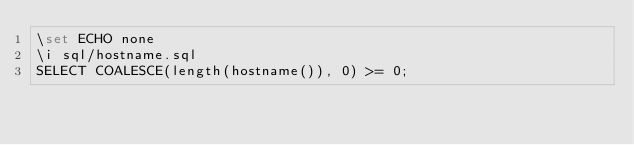<code> <loc_0><loc_0><loc_500><loc_500><_SQL_>\set ECHO none
\i sql/hostname.sql
SELECT COALESCE(length(hostname()), 0) >= 0;
</code> 